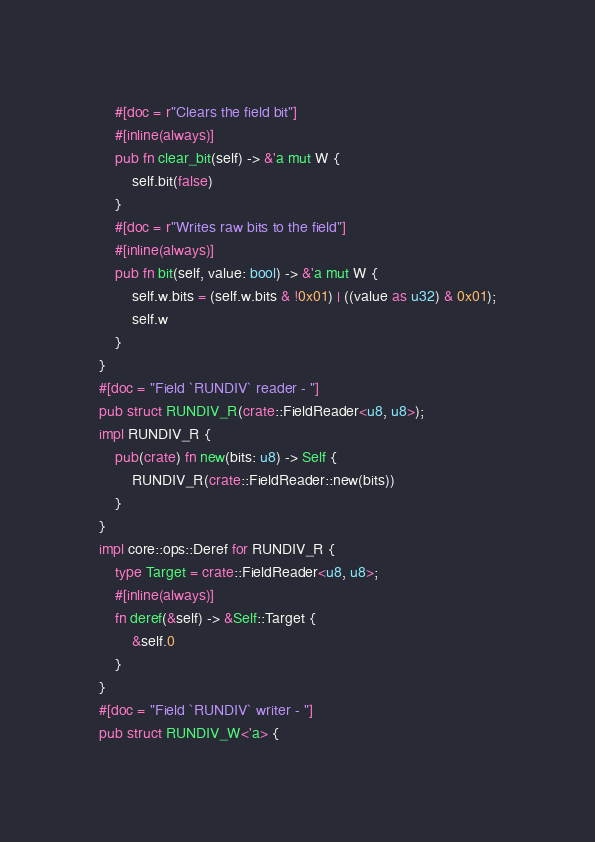Convert code to text. <code><loc_0><loc_0><loc_500><loc_500><_Rust_>    #[doc = r"Clears the field bit"]
    #[inline(always)]
    pub fn clear_bit(self) -> &'a mut W {
        self.bit(false)
    }
    #[doc = r"Writes raw bits to the field"]
    #[inline(always)]
    pub fn bit(self, value: bool) -> &'a mut W {
        self.w.bits = (self.w.bits & !0x01) | ((value as u32) & 0x01);
        self.w
    }
}
#[doc = "Field `RUNDIV` reader - "]
pub struct RUNDIV_R(crate::FieldReader<u8, u8>);
impl RUNDIV_R {
    pub(crate) fn new(bits: u8) -> Self {
        RUNDIV_R(crate::FieldReader::new(bits))
    }
}
impl core::ops::Deref for RUNDIV_R {
    type Target = crate::FieldReader<u8, u8>;
    #[inline(always)]
    fn deref(&self) -> &Self::Target {
        &self.0
    }
}
#[doc = "Field `RUNDIV` writer - "]
pub struct RUNDIV_W<'a> {</code> 